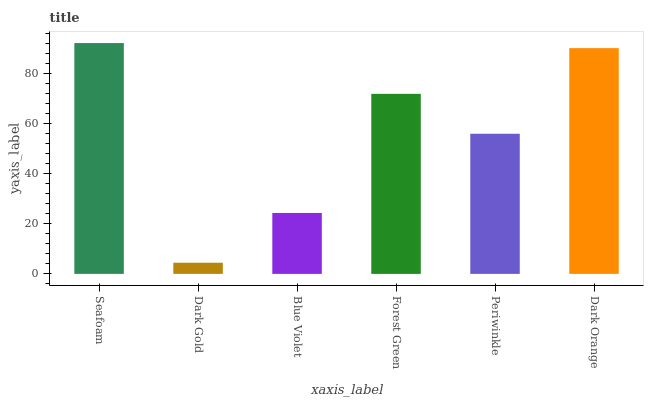Is Dark Gold the minimum?
Answer yes or no. Yes. Is Seafoam the maximum?
Answer yes or no. Yes. Is Blue Violet the minimum?
Answer yes or no. No. Is Blue Violet the maximum?
Answer yes or no. No. Is Blue Violet greater than Dark Gold?
Answer yes or no. Yes. Is Dark Gold less than Blue Violet?
Answer yes or no. Yes. Is Dark Gold greater than Blue Violet?
Answer yes or no. No. Is Blue Violet less than Dark Gold?
Answer yes or no. No. Is Forest Green the high median?
Answer yes or no. Yes. Is Periwinkle the low median?
Answer yes or no. Yes. Is Periwinkle the high median?
Answer yes or no. No. Is Forest Green the low median?
Answer yes or no. No. 